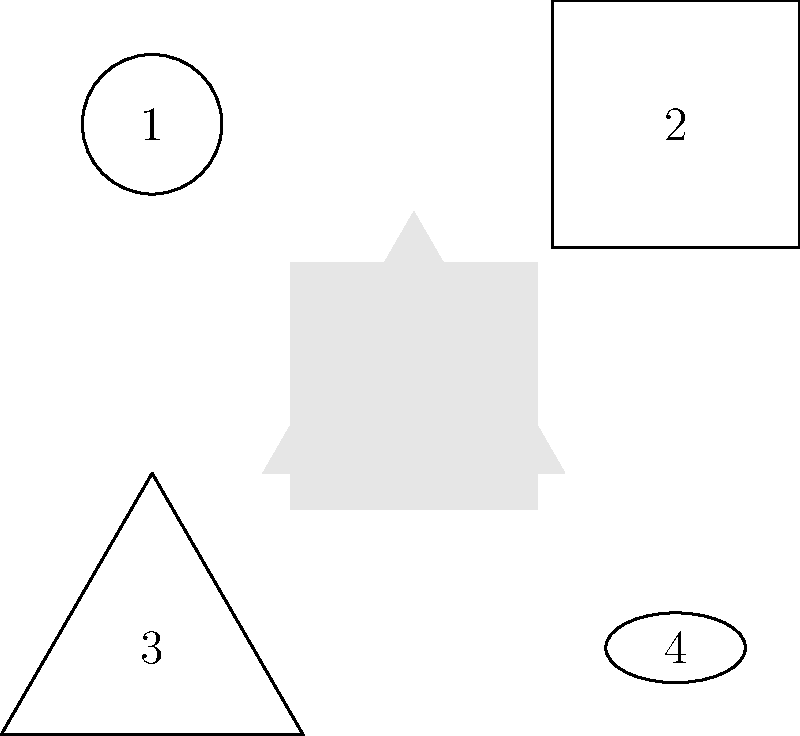As a CPR instructor preparing for various emergency scenarios, you have icons representing different situations: cardiac arrest (1), choking (2), drowning (3), and heat stroke (4). How many unique arrangements of these four icons are possible when creating a quick-reference guide for parents? To determine the number of unique arrangements of the four emergency scenario icons, we need to calculate the number of permutations of 4 distinct objects. Here's the step-by-step explanation:

1. We have 4 distinct icons, each representing a different emergency scenario.
2. The number of permutations of n distinct objects is given by n!
3. In this case, n = 4
4. Therefore, the number of permutations is 4!
5. 4! = 4 × 3 × 2 × 1 = 24

This means there are 24 different ways to arrange these four icons in a quick-reference guide. Each arrangement represents a unique order in which parents could reference these emergency scenarios.

In group theory terms, this relates to the symmetric group $S_4$, which is the group of all permutations on 4 elements. The order of this group is 4!, which equals 24.
Answer: 24 